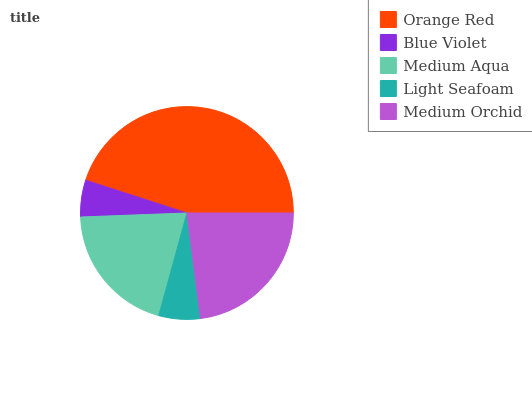Is Blue Violet the minimum?
Answer yes or no. Yes. Is Orange Red the maximum?
Answer yes or no. Yes. Is Medium Aqua the minimum?
Answer yes or no. No. Is Medium Aqua the maximum?
Answer yes or no. No. Is Medium Aqua greater than Blue Violet?
Answer yes or no. Yes. Is Blue Violet less than Medium Aqua?
Answer yes or no. Yes. Is Blue Violet greater than Medium Aqua?
Answer yes or no. No. Is Medium Aqua less than Blue Violet?
Answer yes or no. No. Is Medium Aqua the high median?
Answer yes or no. Yes. Is Medium Aqua the low median?
Answer yes or no. Yes. Is Blue Violet the high median?
Answer yes or no. No. Is Light Seafoam the low median?
Answer yes or no. No. 